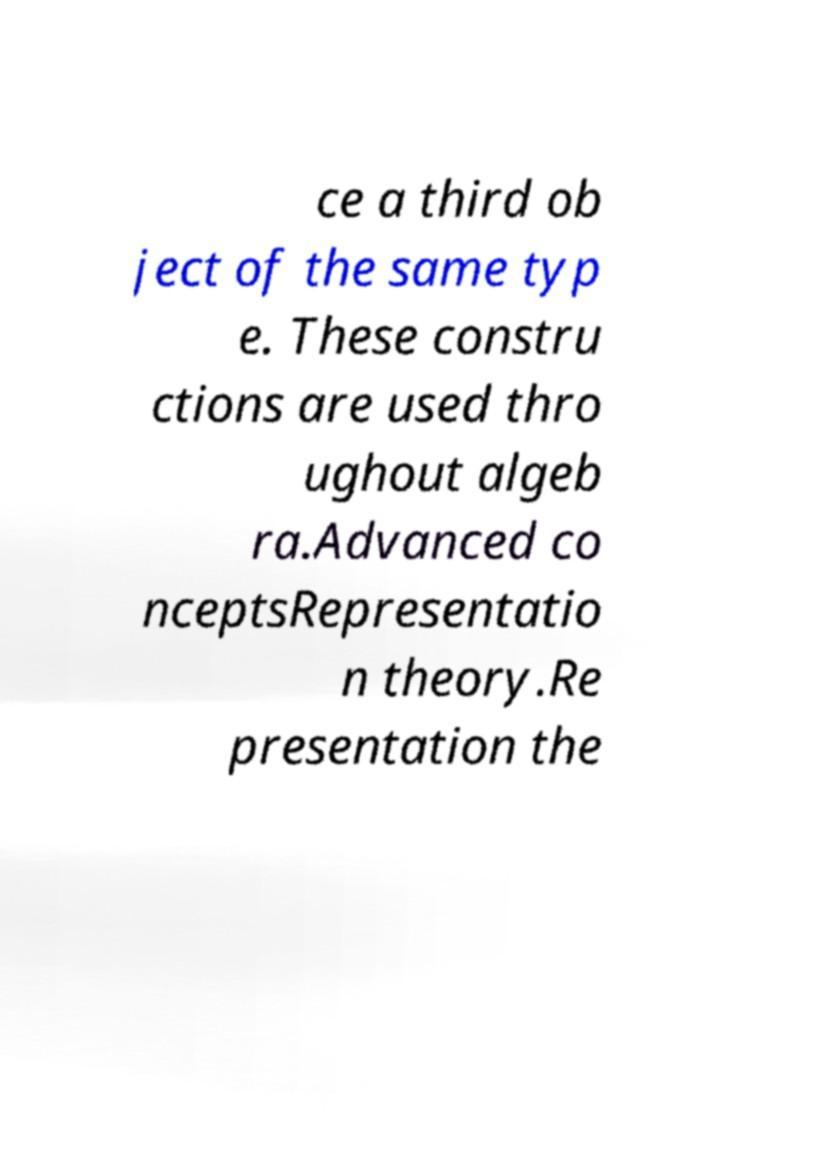Please identify and transcribe the text found in this image. ce a third ob ject of the same typ e. These constru ctions are used thro ughout algeb ra.Advanced co nceptsRepresentatio n theory.Re presentation the 